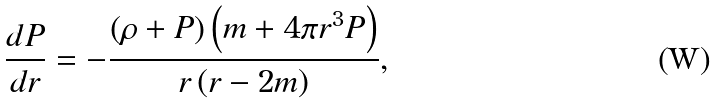Convert formula to latex. <formula><loc_0><loc_0><loc_500><loc_500>\frac { d P } { d r } = - \frac { \left ( \rho + P \right ) \left ( m + 4 \pi r ^ { 3 } P \right ) } { r \left ( r - 2 m \right ) } ,</formula> 